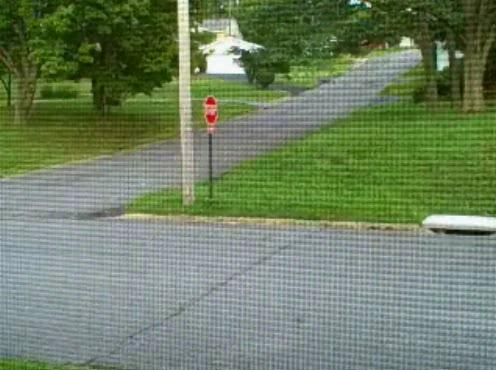What type of road surface can be observed in the image? Asphalt is the road surface material in the image. Are there any distinct objects in the sky? If so, give details. No, there are no distinct objects in the sky in the image. Could you identify the color of the bench present in this image? There is no bench visible in the image. Based on the given information, can you classify the environment in this image? What do you conclude? The image depicts a suburban environment with a road, grassy areas, and trees. Specify the number of green trees next to the field in the image. There are multiple green trees next to the field in the image. Analyze the image and describe the sentiment or atmosphere it portrays. The image portrays a peaceful and calm atmosphere in a suburban setting with green spaces. Count the total number of blue and white planes about to take off in the image. There are no planes visible in the image. Please provide a list of objects and their corresponding colors in the image. Road - asphalt, grass - green, trees - green, stop sign - red and white. Can you recognize a specific street sign in the grass within the image? Yes, there is a stop sign on the grass in the image. What does the long crack appear to be located on in the picture? There is no visible long crack in the image. Observe the two clowns juggling flaming torches beside the stop sign. They are wearing colorful costumes and laughing loudly. This instruction is misleading because there are no clowns or jugglers in the image. Notice the row of abandoned, rusty bicycles leaning against the white bench. The tires are flat, and cobwebs cover the frames. This instruction is misleading because there are no bicycles or a white bench in the image. Find the group of children playing soccer on the green grass beside the road. They are dressed in red uniforms and kicking the ball back and forth. This instruction is misleading because there are no children or soccer players in the image. Can you spot the massive purple elephant standing in the middle of the road? The elephant is wearing a top hat and waving its trunk. This instruction is misleading because there is no elephant in the image. Do you see the exotic, multi-colored parrots perched on the branches of the two big trees in the grass? They are chatting and grooming each other. This instruction is misleading because there are no parrots in the image. Look at the street artist painting a beautiful mural on the side of the big white house. The artwork tells a story about the town's history. This instruction is misleading because there is no street artist or mural in the image. 